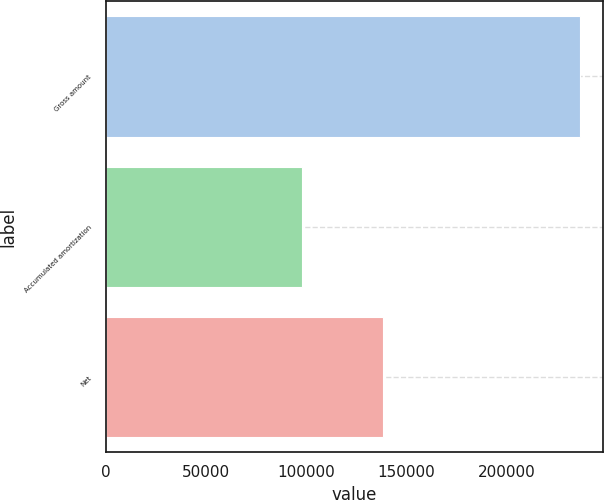Convert chart. <chart><loc_0><loc_0><loc_500><loc_500><bar_chart><fcel>Gross amount<fcel>Accumulated amortization<fcel>Net<nl><fcel>236594<fcel>98090<fcel>138504<nl></chart> 